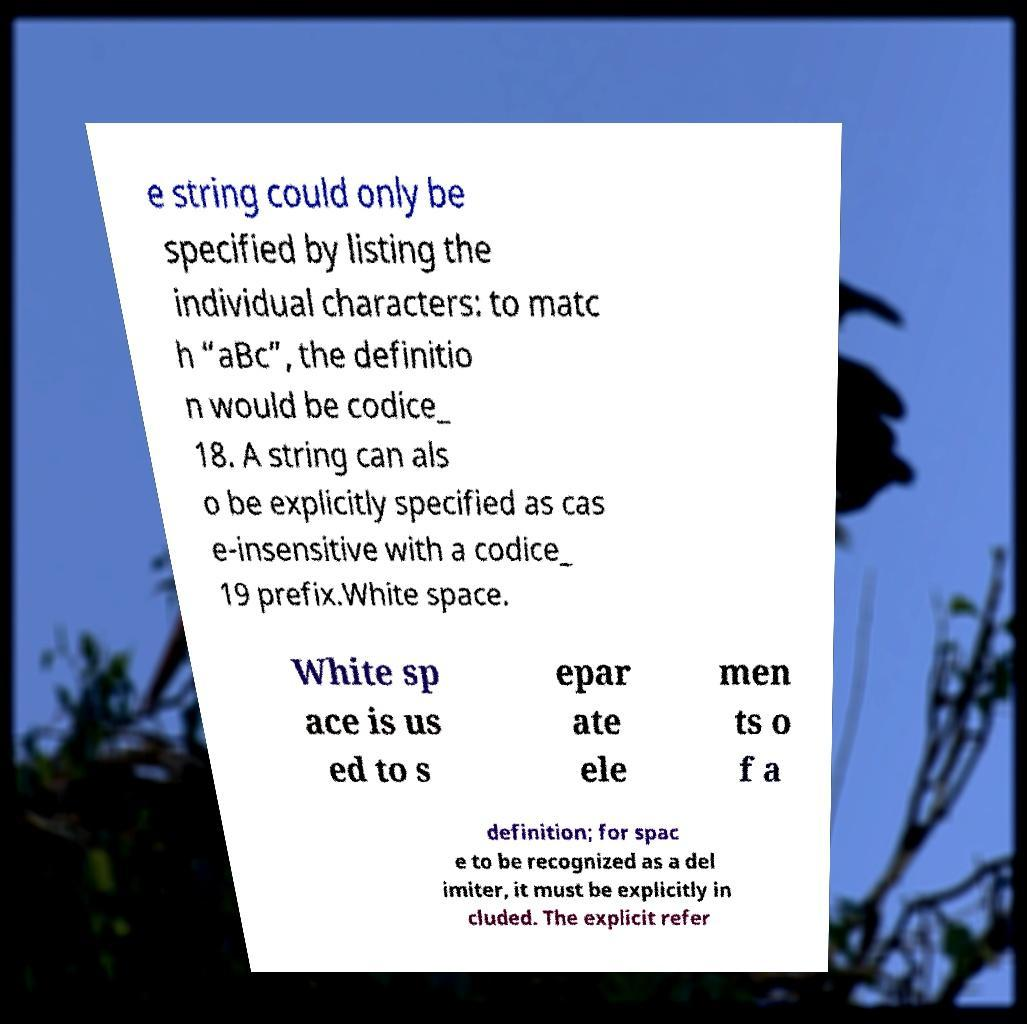Please read and relay the text visible in this image. What does it say? e string could only be specified by listing the individual characters: to matc h “aBc”, the definitio n would be codice_ 18. A string can als o be explicitly specified as cas e-insensitive with a codice_ 19 prefix.White space. White sp ace is us ed to s epar ate ele men ts o f a definition; for spac e to be recognized as a del imiter, it must be explicitly in cluded. The explicit refer 